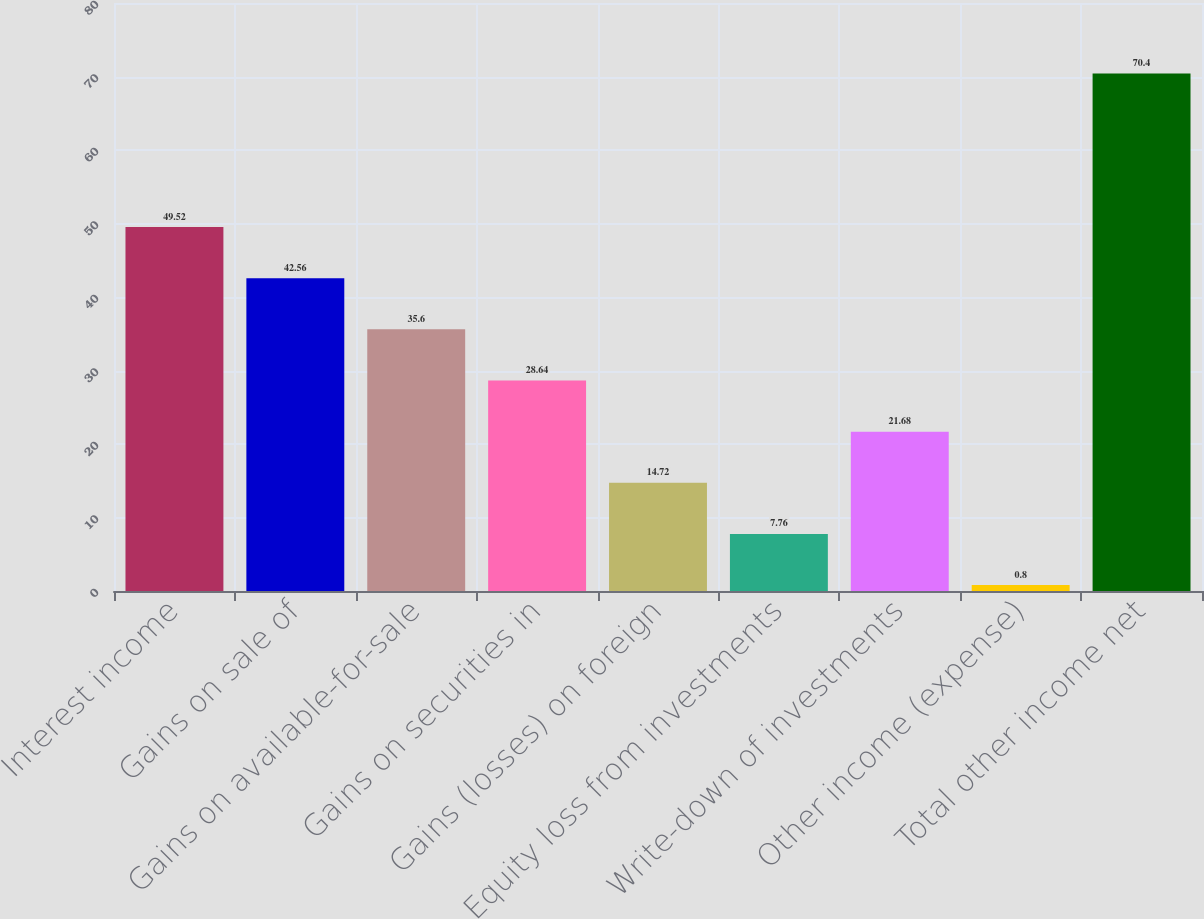<chart> <loc_0><loc_0><loc_500><loc_500><bar_chart><fcel>Interest income<fcel>Gains on sale of<fcel>Gains on available-for-sale<fcel>Gains on securities in<fcel>Gains (losses) on foreign<fcel>Equity loss from investments<fcel>Write-down of investments<fcel>Other income (expense)<fcel>Total other income net<nl><fcel>49.52<fcel>42.56<fcel>35.6<fcel>28.64<fcel>14.72<fcel>7.76<fcel>21.68<fcel>0.8<fcel>70.4<nl></chart> 